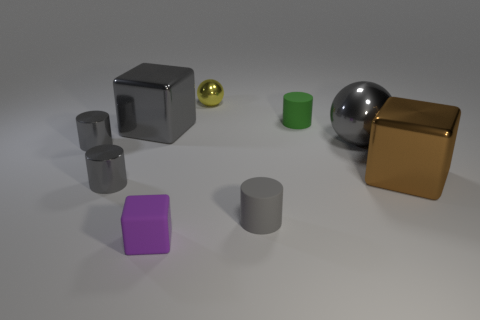Subtract all gray cylinders. How many cylinders are left? 1 Subtract all yellow spheres. How many gray cylinders are left? 3 Subtract 1 cylinders. How many cylinders are left? 3 Subtract all green cylinders. How many cylinders are left? 3 Subtract all blue cylinders. Subtract all yellow blocks. How many cylinders are left? 4 Subtract 0 brown balls. How many objects are left? 9 Subtract all cylinders. How many objects are left? 5 Subtract all red matte cubes. Subtract all tiny yellow objects. How many objects are left? 8 Add 3 green matte cylinders. How many green matte cylinders are left? 4 Add 2 small purple cubes. How many small purple cubes exist? 3 